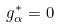Convert formula to latex. <formula><loc_0><loc_0><loc_500><loc_500>g _ { \alpha } ^ { * } = 0</formula> 